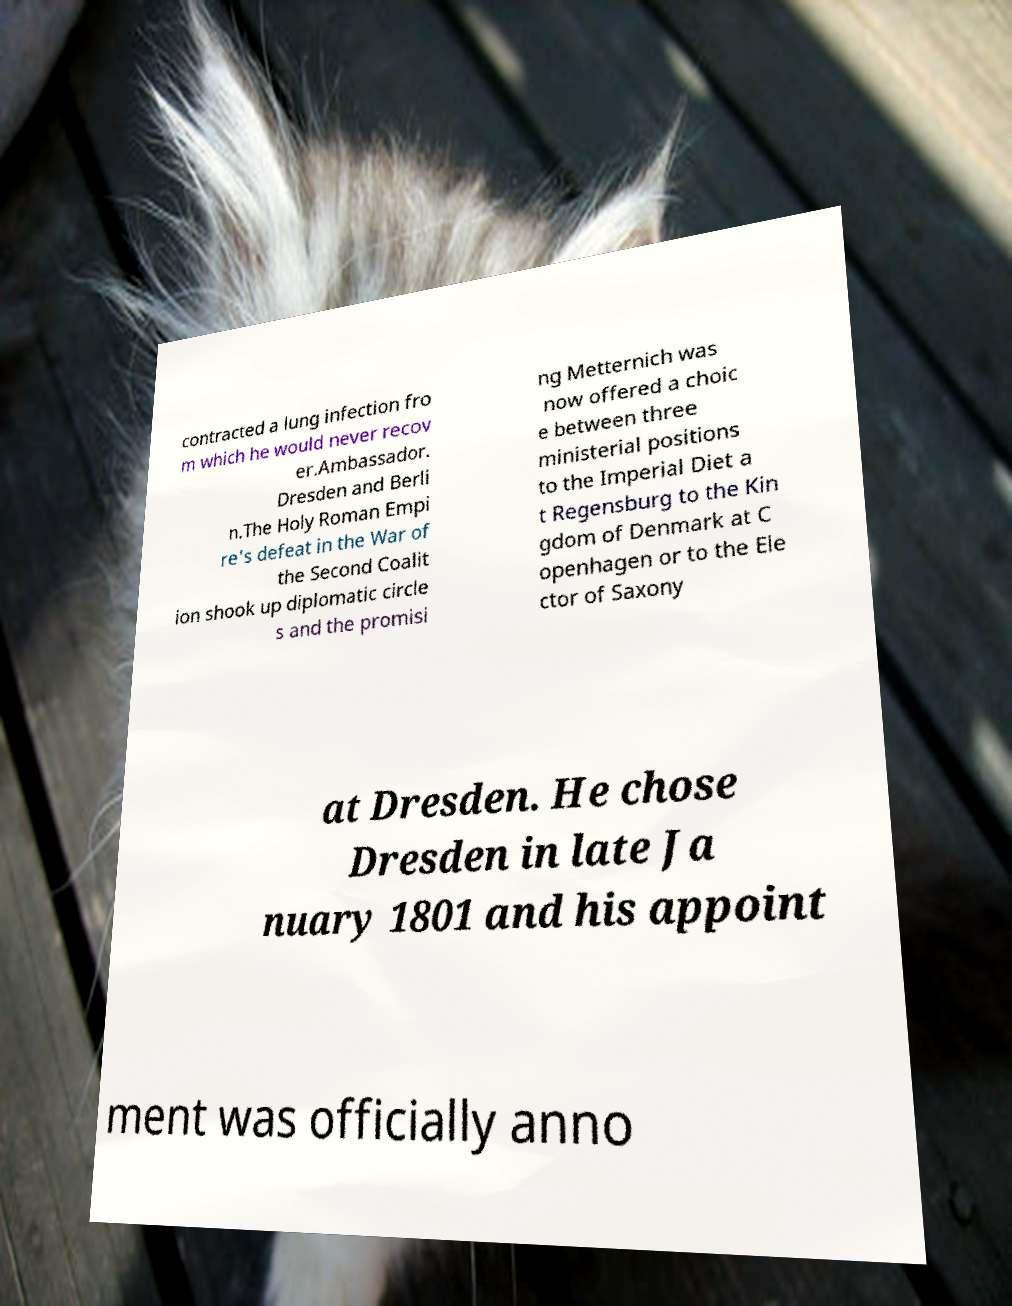Can you read and provide the text displayed in the image?This photo seems to have some interesting text. Can you extract and type it out for me? contracted a lung infection fro m which he would never recov er.Ambassador. Dresden and Berli n.The Holy Roman Empi re's defeat in the War of the Second Coalit ion shook up diplomatic circle s and the promisi ng Metternich was now offered a choic e between three ministerial positions to the Imperial Diet a t Regensburg to the Kin gdom of Denmark at C openhagen or to the Ele ctor of Saxony at Dresden. He chose Dresden in late Ja nuary 1801 and his appoint ment was officially anno 